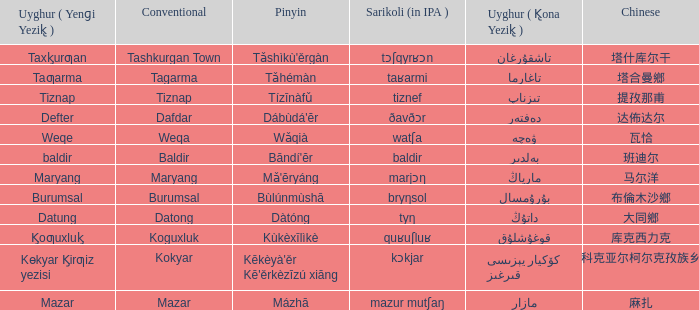Name the pinyin for تىزناپ Tízīnàfǔ. 